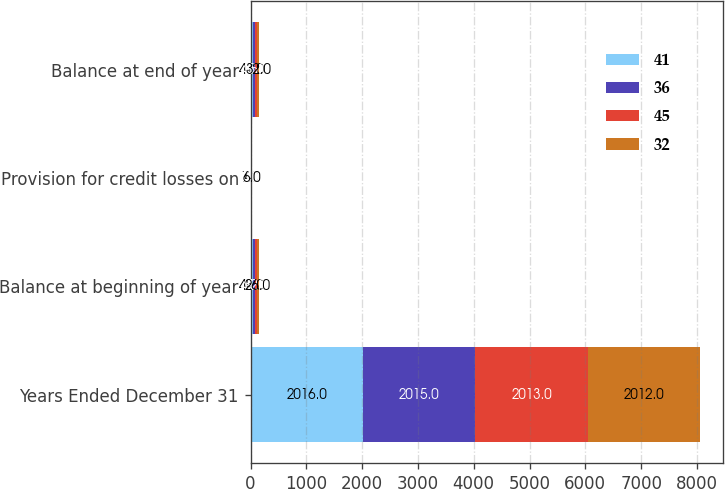<chart> <loc_0><loc_0><loc_500><loc_500><stacked_bar_chart><ecel><fcel>Years Ended December 31<fcel>Balance at beginning of year<fcel>Provision for credit losses on<fcel>Balance at end of year<nl><fcel>41<fcel>2016<fcel>45<fcel>7<fcel>41<nl><fcel>36<fcel>2015<fcel>41<fcel>5<fcel>45<nl><fcel>45<fcel>2013<fcel>32<fcel>4<fcel>36<nl><fcel>32<fcel>2012<fcel>26<fcel>6<fcel>32<nl></chart> 